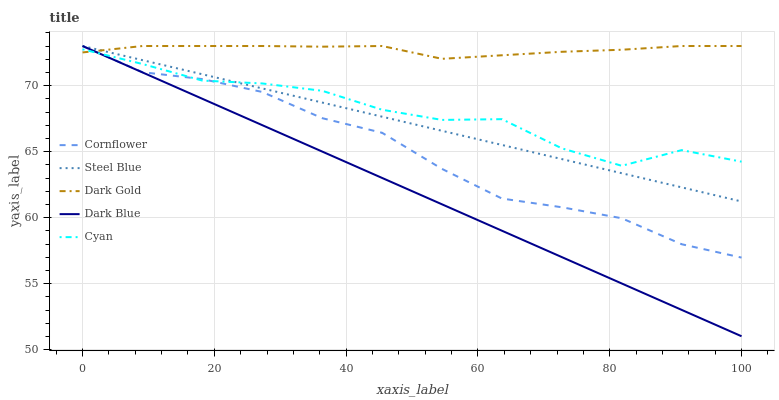Does Dark Blue have the minimum area under the curve?
Answer yes or no. Yes. Does Dark Gold have the maximum area under the curve?
Answer yes or no. Yes. Does Cyan have the minimum area under the curve?
Answer yes or no. No. Does Cyan have the maximum area under the curve?
Answer yes or no. No. Is Dark Blue the smoothest?
Answer yes or no. Yes. Is Cyan the roughest?
Answer yes or no. Yes. Is Cyan the smoothest?
Answer yes or no. No. Is Dark Blue the roughest?
Answer yes or no. No. Does Dark Blue have the lowest value?
Answer yes or no. Yes. Does Cyan have the lowest value?
Answer yes or no. No. Does Dark Gold have the highest value?
Answer yes or no. Yes. Does Cyan have the highest value?
Answer yes or no. No. Does Dark Blue intersect Cyan?
Answer yes or no. Yes. Is Dark Blue less than Cyan?
Answer yes or no. No. Is Dark Blue greater than Cyan?
Answer yes or no. No. 